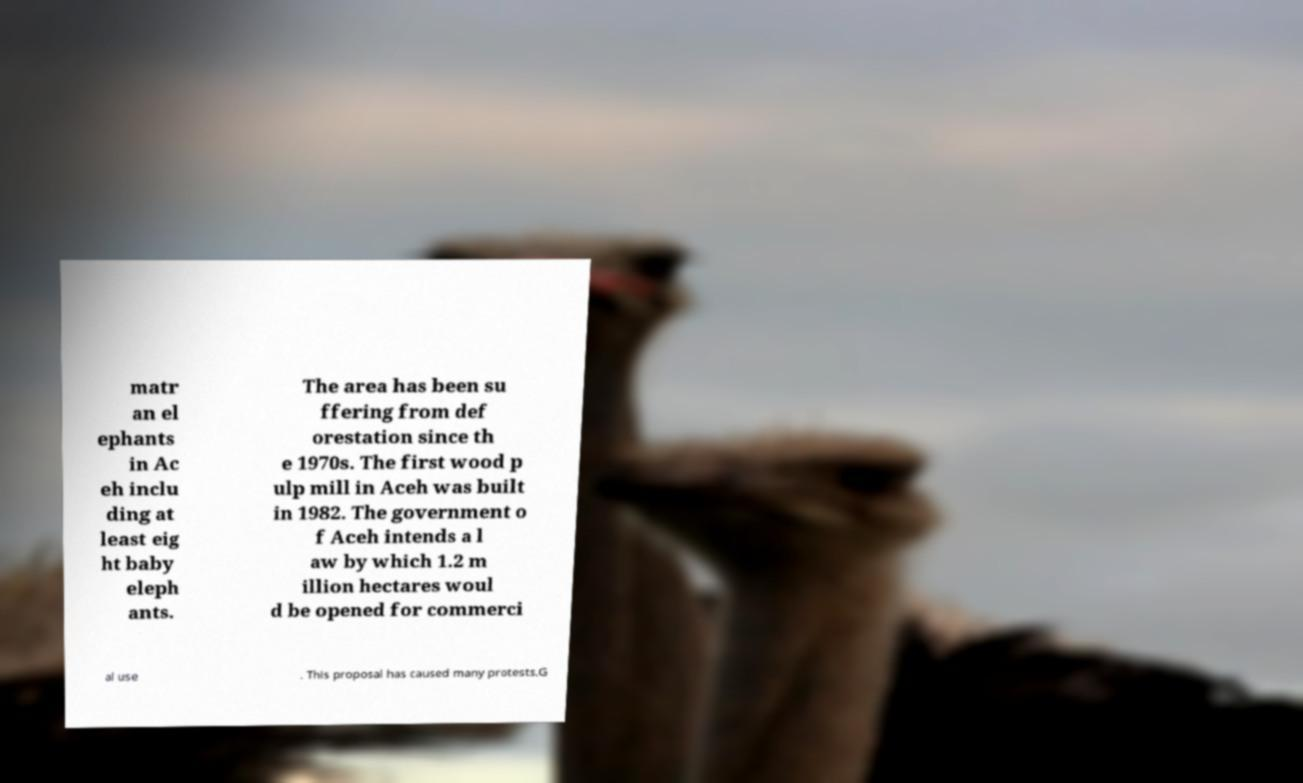Could you assist in decoding the text presented in this image and type it out clearly? matr an el ephants in Ac eh inclu ding at least eig ht baby eleph ants. The area has been su ffering from def orestation since th e 1970s. The first wood p ulp mill in Aceh was built in 1982. The government o f Aceh intends a l aw by which 1.2 m illion hectares woul d be opened for commerci al use . This proposal has caused many protests.G 